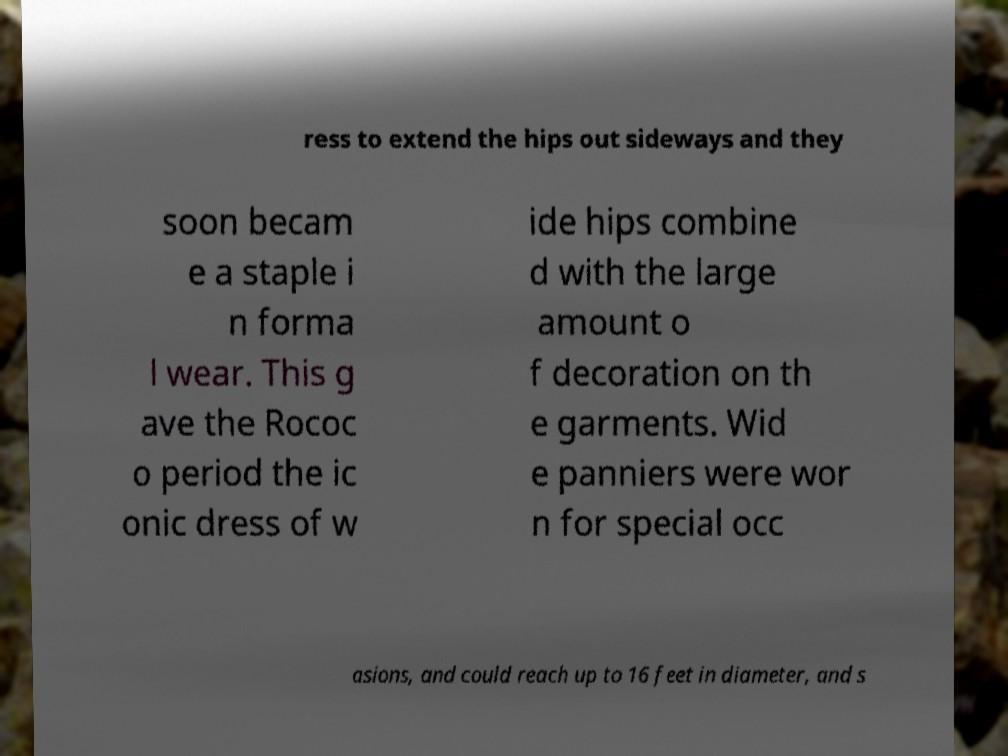For documentation purposes, I need the text within this image transcribed. Could you provide that? ress to extend the hips out sideways and they soon becam e a staple i n forma l wear. This g ave the Rococ o period the ic onic dress of w ide hips combine d with the large amount o f decoration on th e garments. Wid e panniers were wor n for special occ asions, and could reach up to 16 feet in diameter, and s 